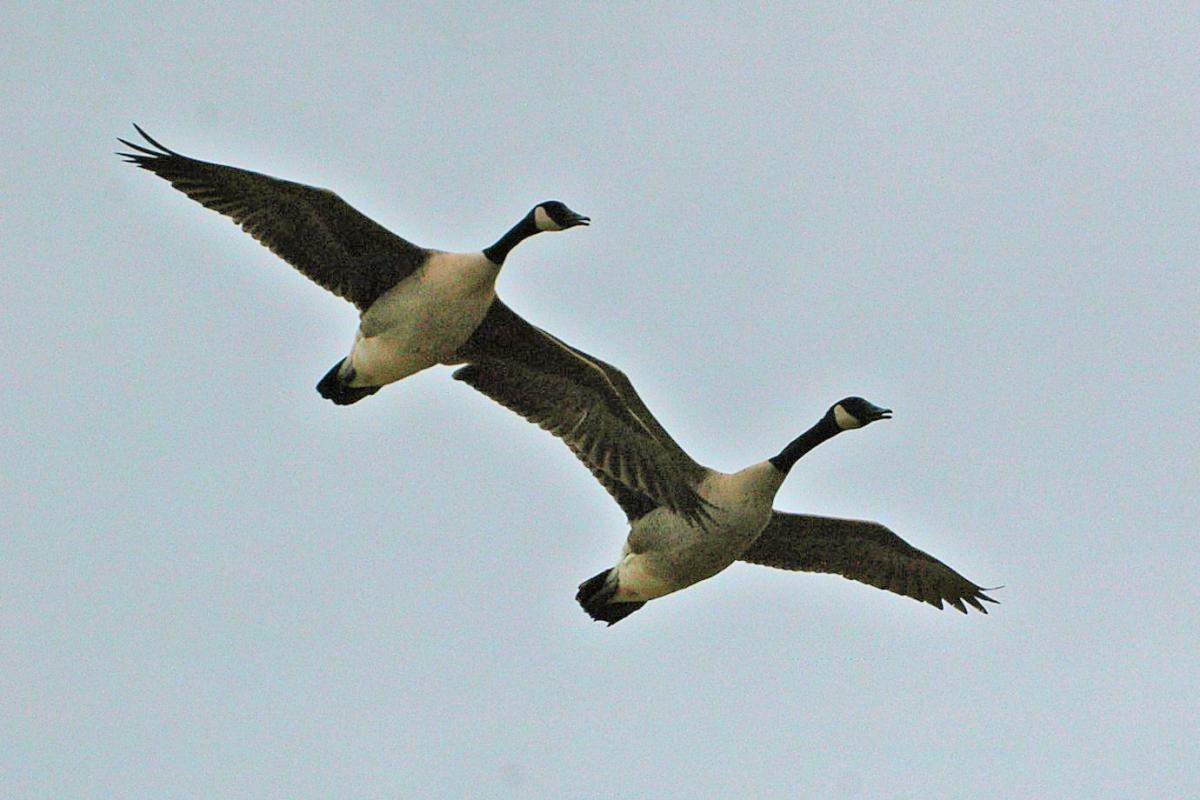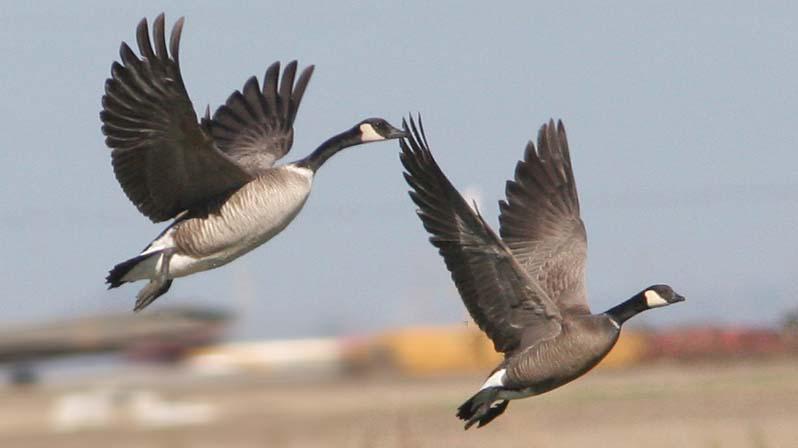The first image is the image on the left, the second image is the image on the right. Evaluate the accuracy of this statement regarding the images: "The right image contains more birds than the left image.". Is it true? Answer yes or no. No. 